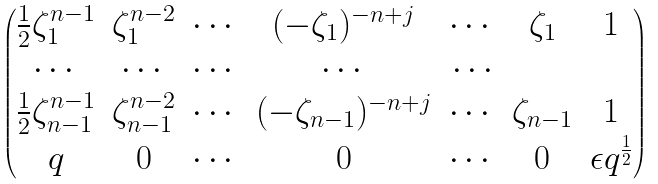Convert formula to latex. <formula><loc_0><loc_0><loc_500><loc_500>\begin{pmatrix} \frac { 1 } { 2 } \zeta _ { 1 } ^ { n - 1 } & \zeta _ { 1 } ^ { n - 2 } & \cdots & ( - \zeta _ { 1 } ) ^ { - n + j } & \cdots & \zeta _ { 1 } & 1 \\ \cdots & \cdots & \cdots & \cdots & \cdots \\ \frac { 1 } { 2 } \zeta _ { n - 1 } ^ { n - 1 } & \zeta _ { n - 1 } ^ { n - 2 } & \cdots & ( - \zeta _ { n - 1 } ) ^ { - n + j } & \cdots & \zeta _ { n - 1 } & 1 \\ q & 0 & \cdots & 0 & \cdots & 0 & \epsilon q ^ { \frac { 1 } { 2 } } \end{pmatrix}</formula> 